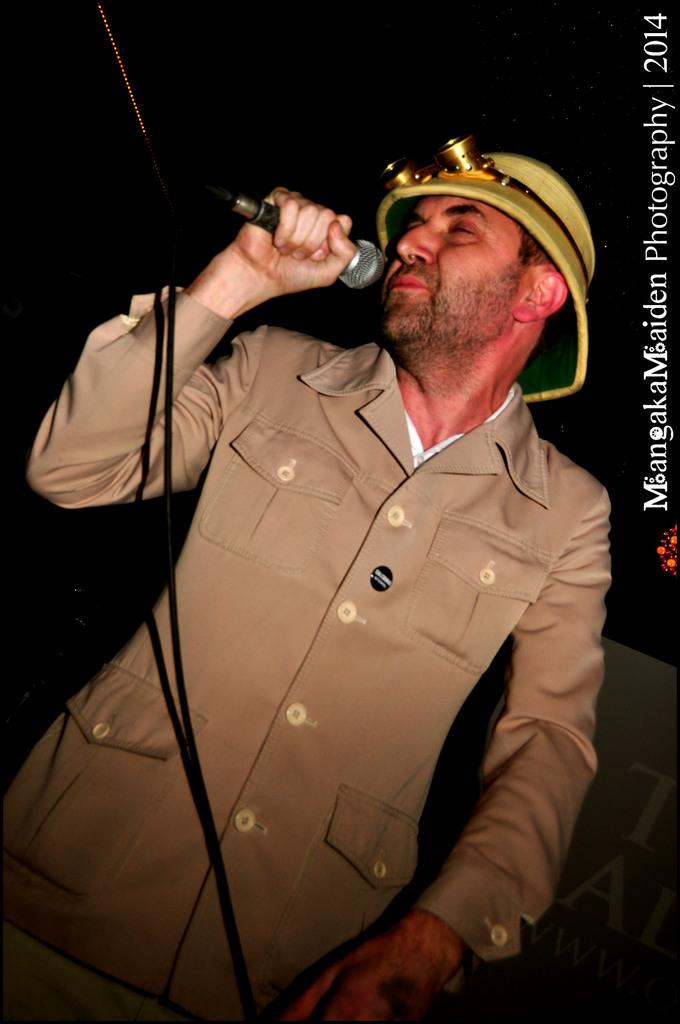What can be seen in the image? There is a person in the image. What is the person wearing? The person is wearing a helmet. What is the person holding? The person is holding a microphone (mike). What information is provided on the right side of the image? The text says "mangaka maiden photography 2014". Where is the engine located in the image? There is no engine present in the image. What type of books can be found in the library depicted in the image? There is no library depicted in the image. 